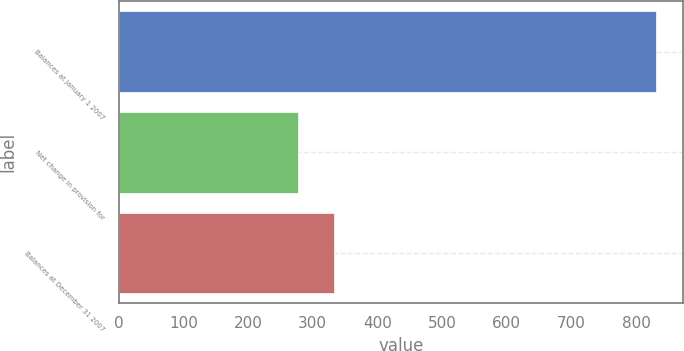<chart> <loc_0><loc_0><loc_500><loc_500><bar_chart><fcel>Balances at January 1 2007<fcel>Net change in provision for<fcel>Balances at December 31 2007<nl><fcel>830.7<fcel>277.7<fcel>333<nl></chart> 